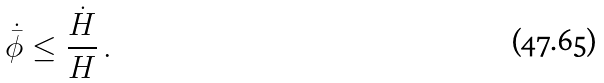Convert formula to latex. <formula><loc_0><loc_0><loc_500><loc_500>\dot { \bar { \phi } } \leq \frac { \dot { H } } { H } \, .</formula> 